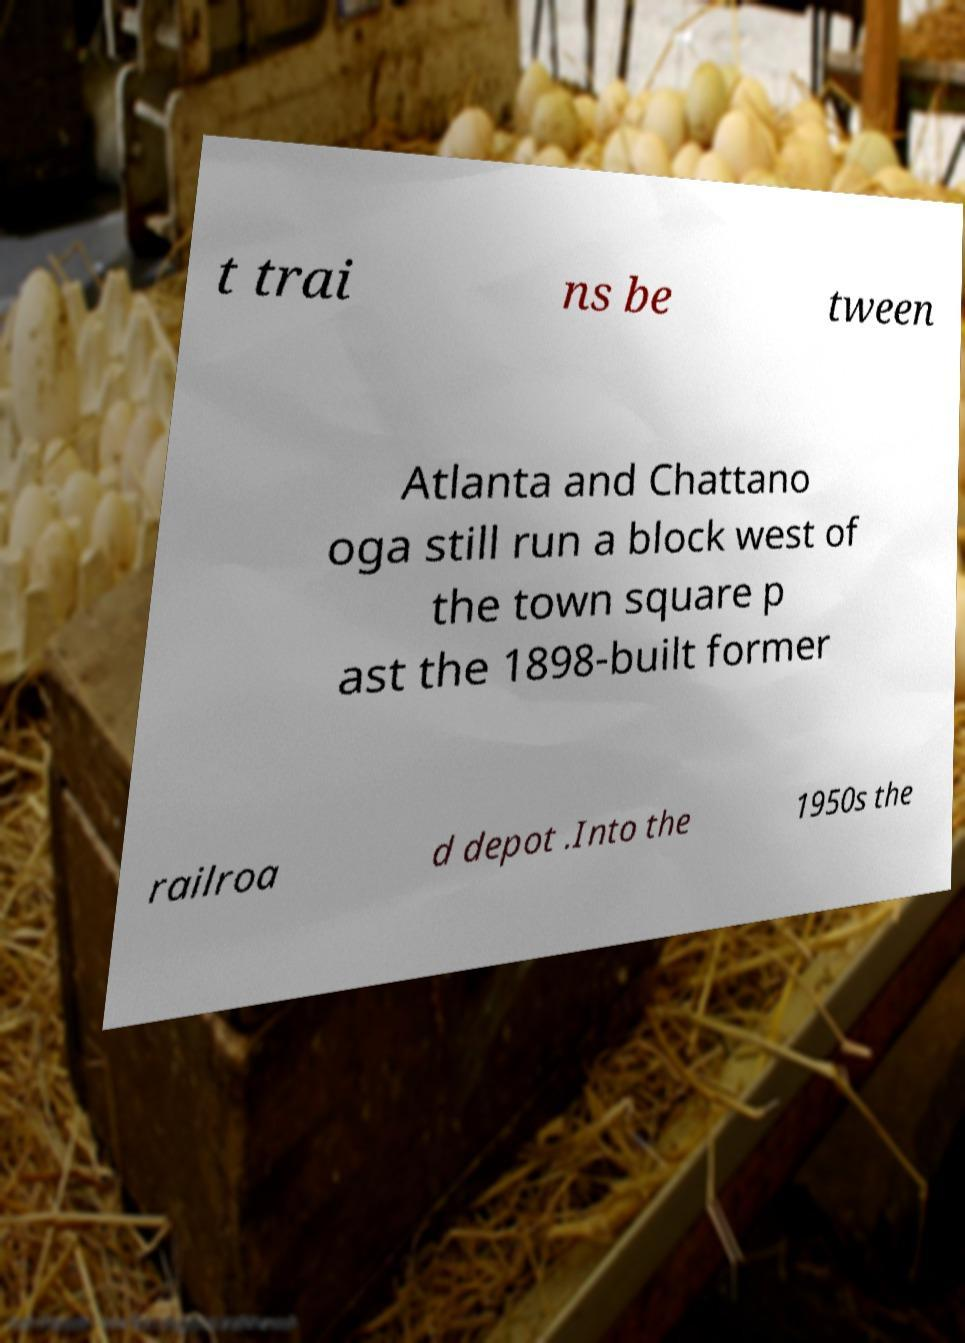I need the written content from this picture converted into text. Can you do that? t trai ns be tween Atlanta and Chattano oga still run a block west of the town square p ast the 1898-built former railroa d depot .Into the 1950s the 